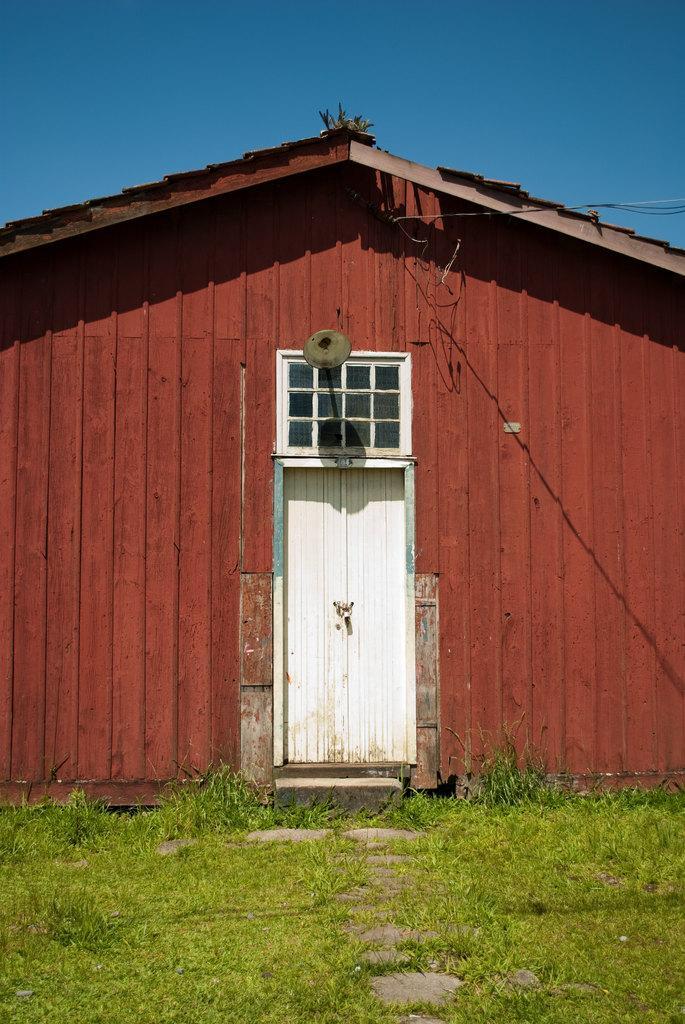How would you summarize this image in a sentence or two? In this image there is a house, door. At the top of the image there is sky. At the bottom of the image there is grass. 